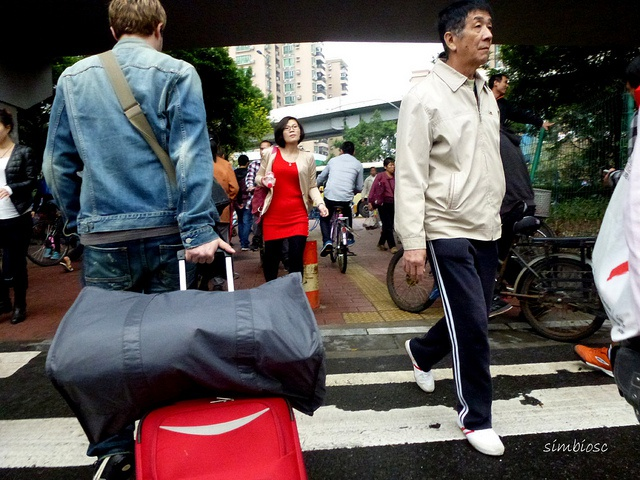Describe the objects in this image and their specific colors. I can see people in black, gray, and blue tones, people in black, lightgray, and darkgray tones, suitcase in black, brown, lightgray, and red tones, bicycle in black, gray, and maroon tones, and people in black, lightgray, darkgray, and gray tones in this image. 